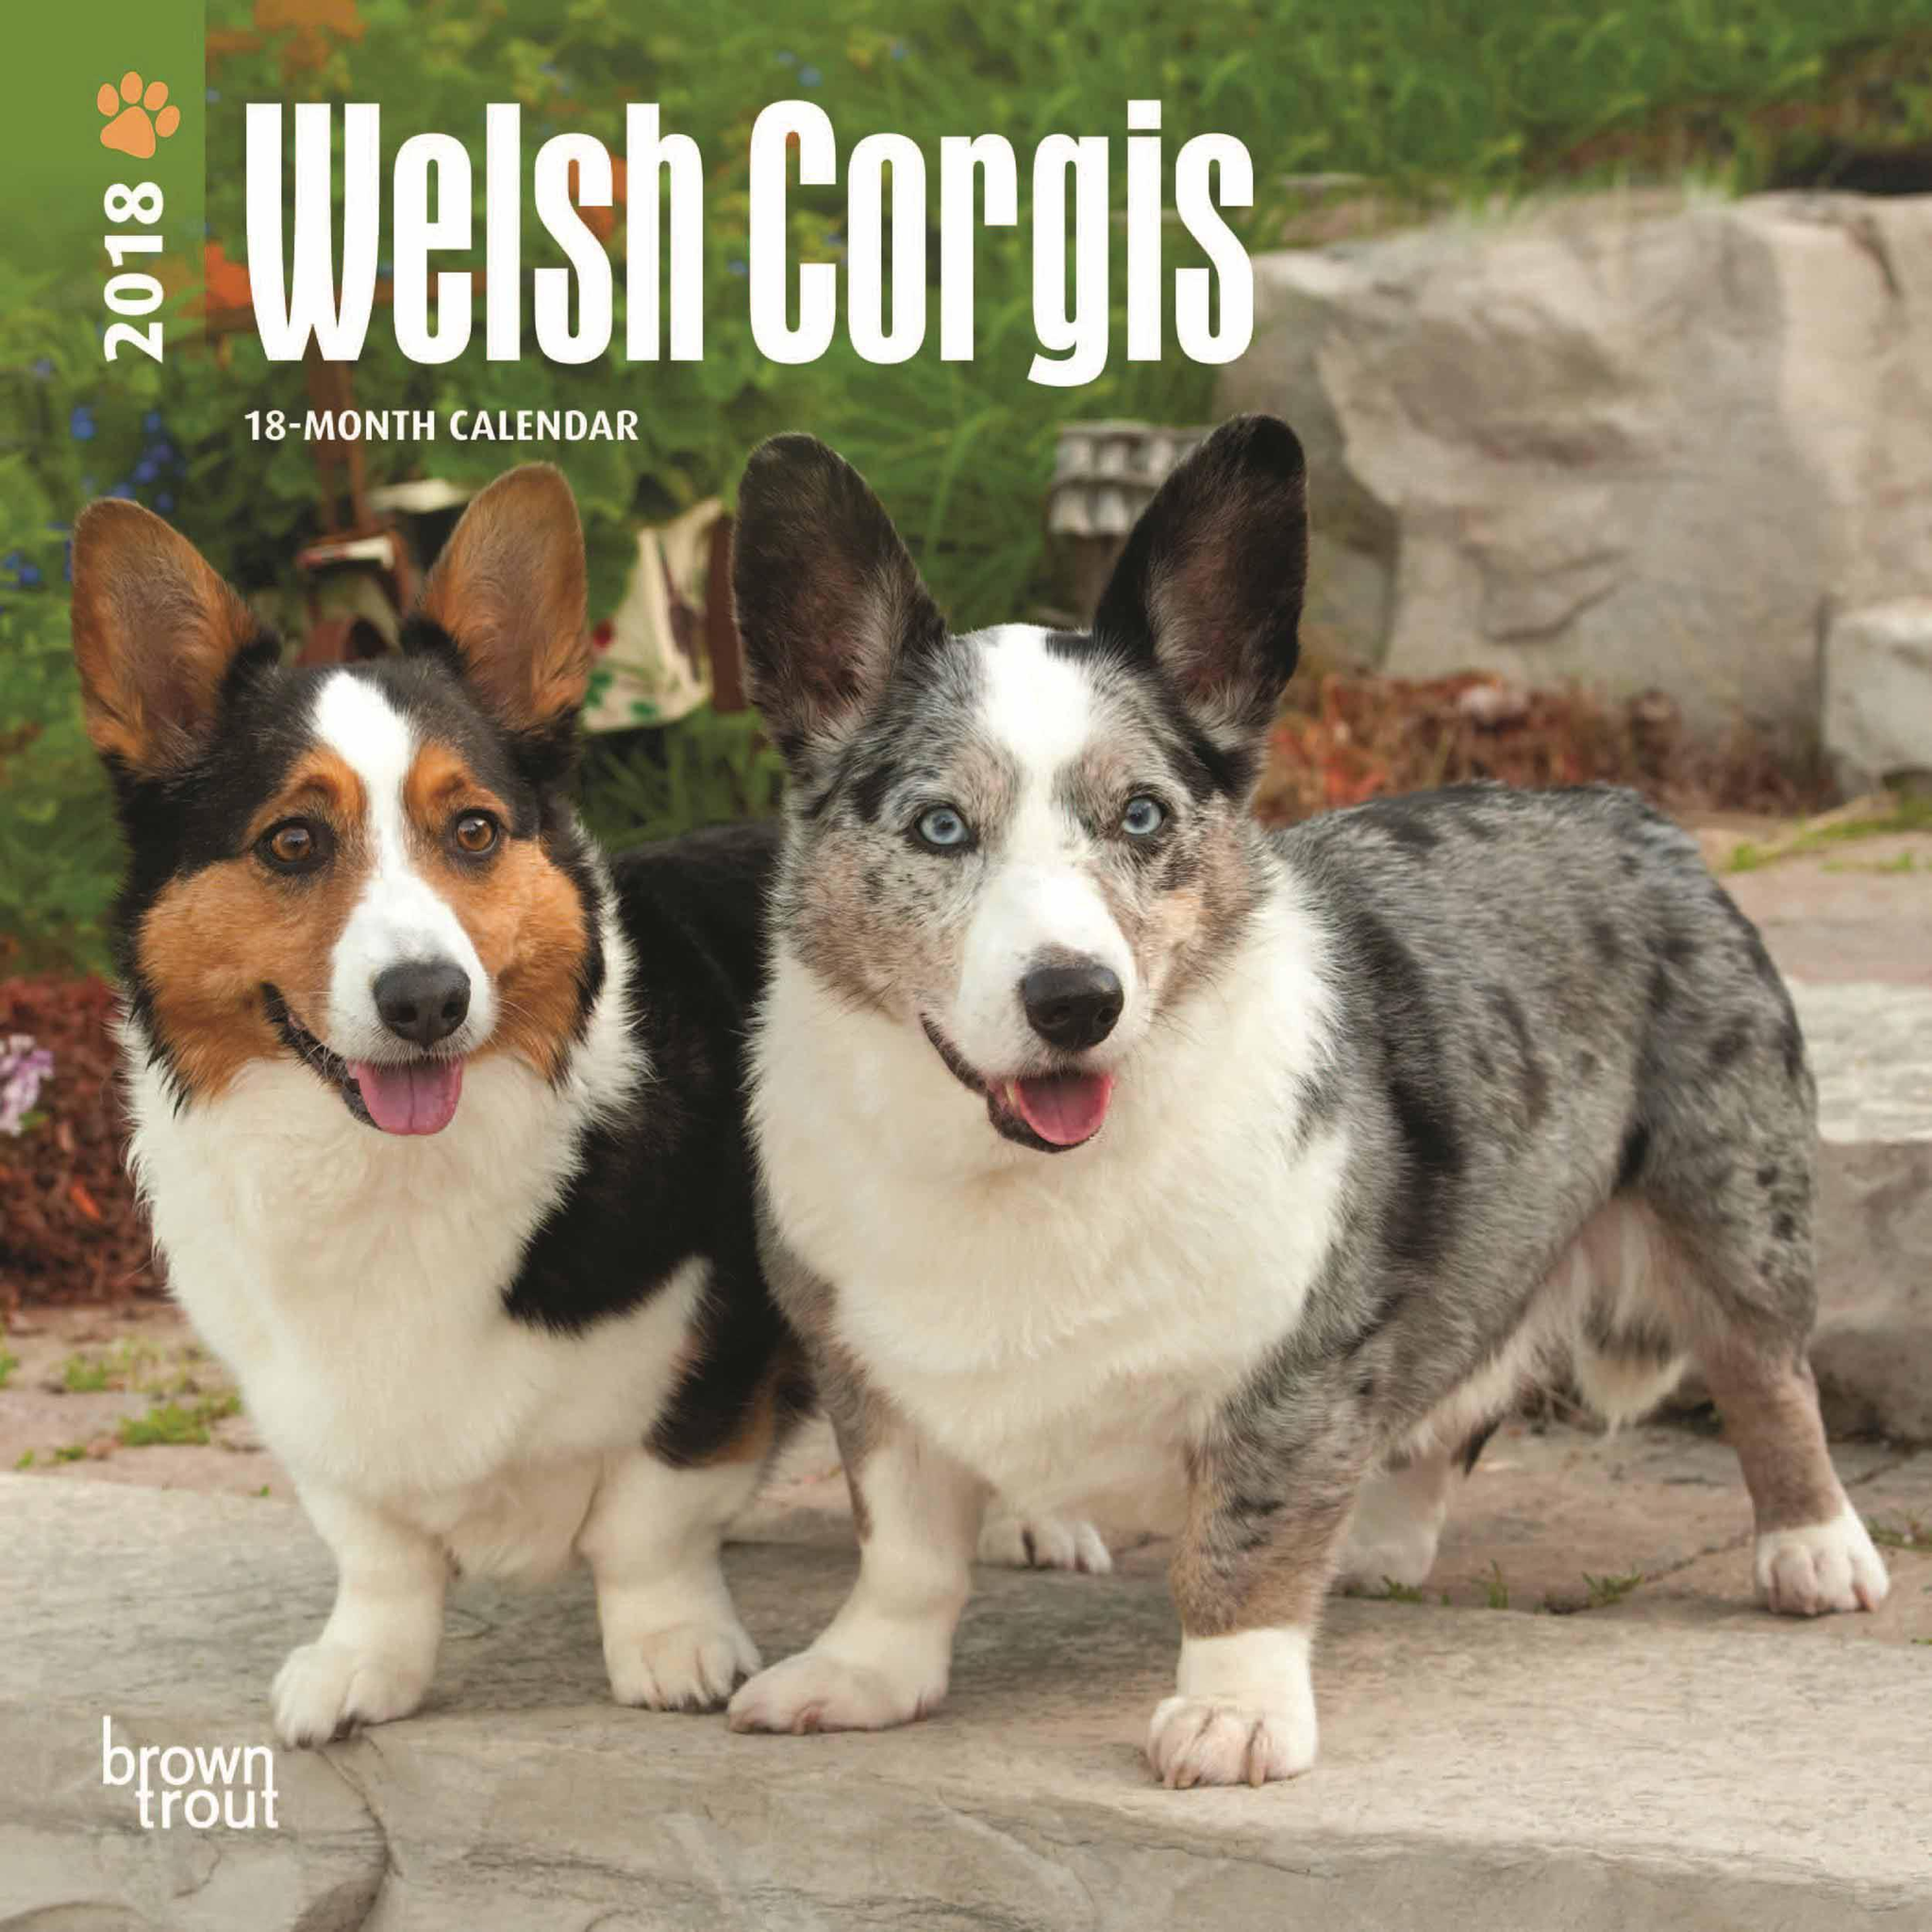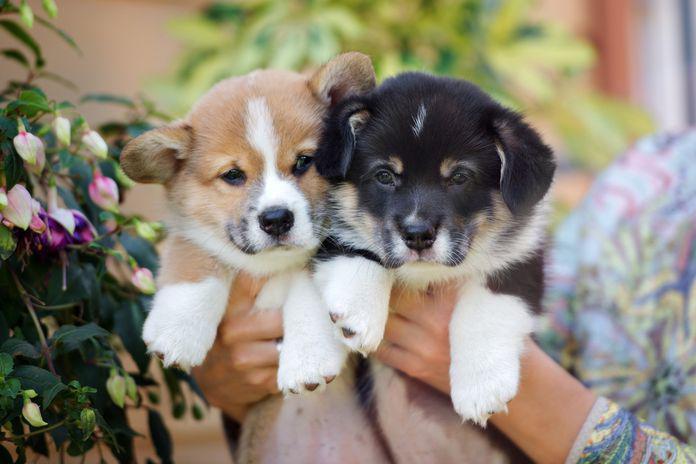The first image is the image on the left, the second image is the image on the right. Given the left and right images, does the statement "The right image contains at least two dogs." hold true? Answer yes or no. Yes. The first image is the image on the left, the second image is the image on the right. Evaluate the accuracy of this statement regarding the images: "Less than four corgis are in the pair.". Is it true? Answer yes or no. No. 